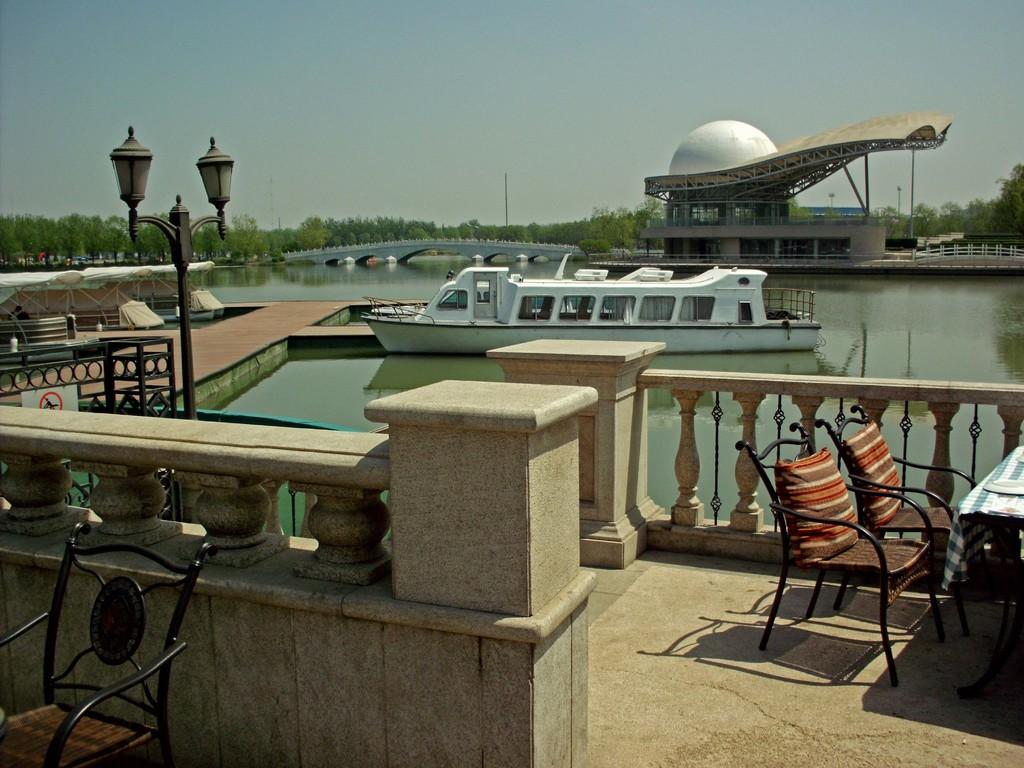What type of boat is in the image? There is a white color boat in the image. Where is the boat located? The boat is on the water. What type of furniture can be seen in the image? There are chairs in the image. What type of structure is present in the image? There is a bridge in the image. What type of vegetation is visible in the image? There are green trees in the image. What is visible in the sky in the image? The sky is visible in the image, and it is cloudy. What type of trousers is the boat wearing in the image? Boats do not wear trousers, as they are inanimate objects. The question is not relevant to the image. 